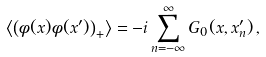Convert formula to latex. <formula><loc_0><loc_0><loc_500><loc_500>\left \langle \left ( \phi ( x ) \phi ( x ^ { \prime } ) \right ) _ { + } \right \rangle = - i \sum _ { n = - \infty } ^ { \infty } G _ { 0 } ( x , x ^ { \prime } _ { n } ) \, ,</formula> 